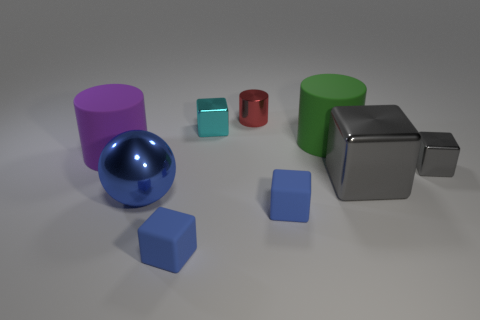Subtract all blue cubes. How many cubes are left? 3 Subtract all purple balls. How many blue cubes are left? 2 Subtract all blue cubes. How many cubes are left? 3 Subtract 1 cylinders. How many cylinders are left? 2 Add 1 big purple metal balls. How many objects exist? 10 Subtract all cylinders. How many objects are left? 6 Add 1 balls. How many balls exist? 2 Subtract 0 brown spheres. How many objects are left? 9 Subtract all green cylinders. Subtract all purple balls. How many cylinders are left? 2 Subtract all green metallic cylinders. Subtract all rubber things. How many objects are left? 5 